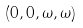Convert formula to latex. <formula><loc_0><loc_0><loc_500><loc_500>( 0 , 0 , \omega , \omega )</formula> 